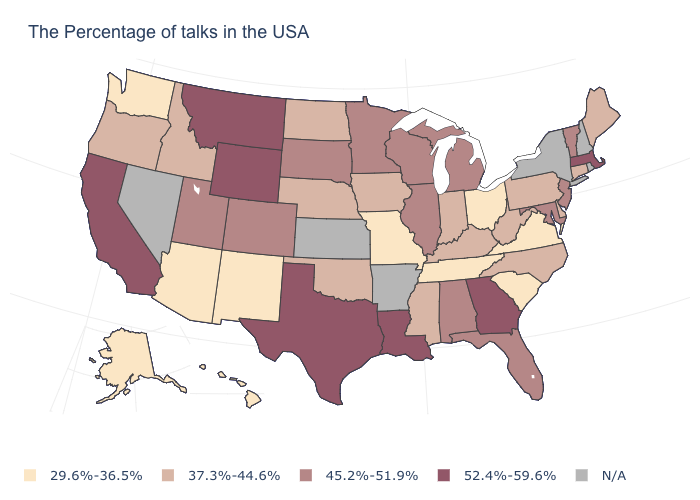What is the value of Oregon?
Write a very short answer. 37.3%-44.6%. How many symbols are there in the legend?
Short answer required. 5. Name the states that have a value in the range 37.3%-44.6%?
Quick response, please. Maine, Connecticut, Delaware, Pennsylvania, North Carolina, West Virginia, Kentucky, Indiana, Mississippi, Iowa, Nebraska, Oklahoma, North Dakota, Idaho, Oregon. Does the map have missing data?
Give a very brief answer. Yes. Name the states that have a value in the range 29.6%-36.5%?
Concise answer only. Virginia, South Carolina, Ohio, Tennessee, Missouri, New Mexico, Arizona, Washington, Alaska, Hawaii. Among the states that border South Dakota , which have the lowest value?
Be succinct. Iowa, Nebraska, North Dakota. Which states have the highest value in the USA?
Keep it brief. Massachusetts, Georgia, Louisiana, Texas, Wyoming, Montana, California. What is the value of Michigan?
Keep it brief. 45.2%-51.9%. Name the states that have a value in the range 29.6%-36.5%?
Answer briefly. Virginia, South Carolina, Ohio, Tennessee, Missouri, New Mexico, Arizona, Washington, Alaska, Hawaii. What is the value of North Dakota?
Write a very short answer. 37.3%-44.6%. Does the first symbol in the legend represent the smallest category?
Keep it brief. Yes. Name the states that have a value in the range 29.6%-36.5%?
Concise answer only. Virginia, South Carolina, Ohio, Tennessee, Missouri, New Mexico, Arizona, Washington, Alaska, Hawaii. What is the value of Oregon?
Give a very brief answer. 37.3%-44.6%. What is the lowest value in the South?
Quick response, please. 29.6%-36.5%. 